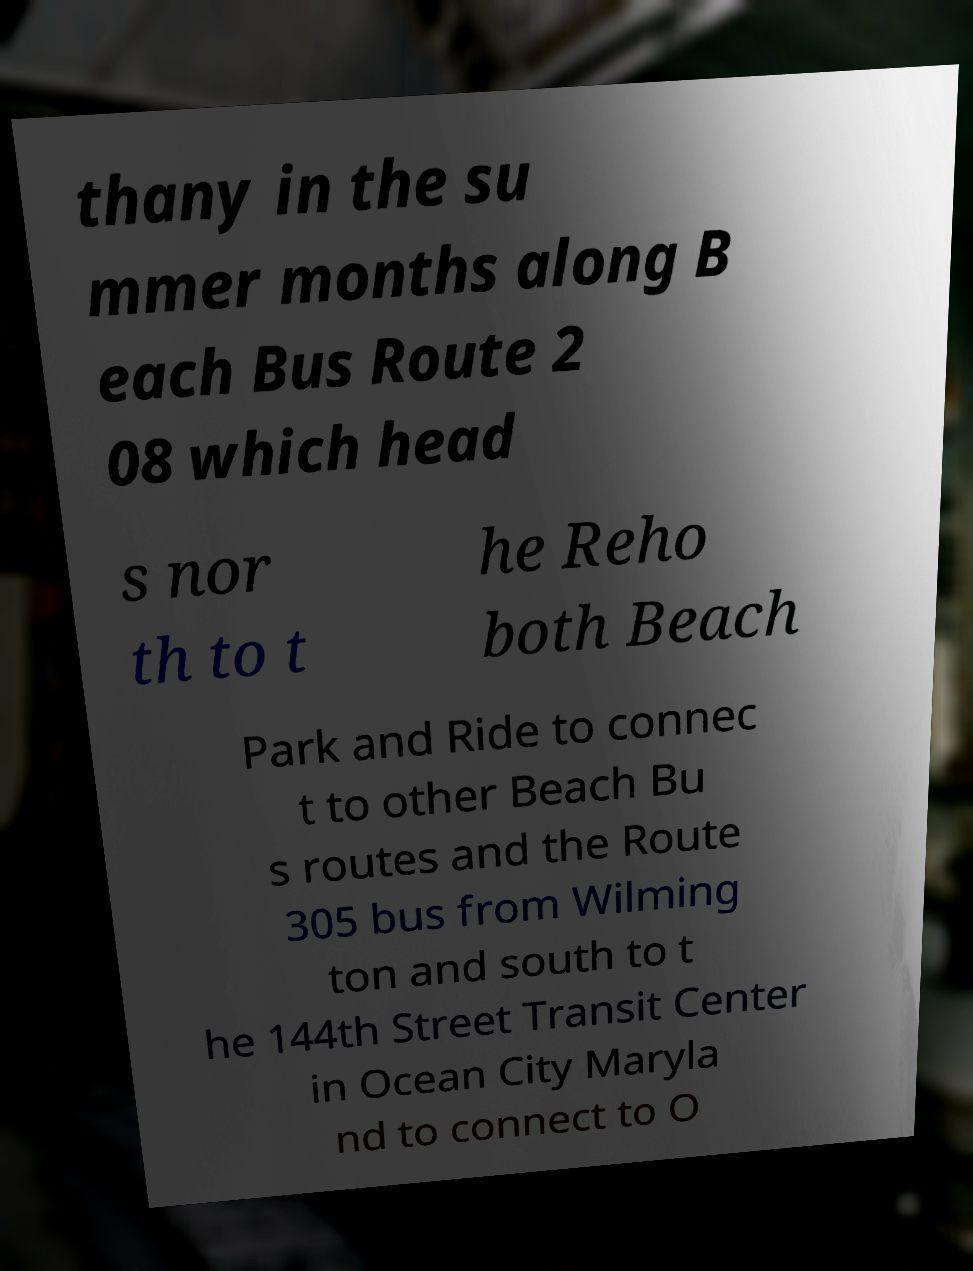There's text embedded in this image that I need extracted. Can you transcribe it verbatim? thany in the su mmer months along B each Bus Route 2 08 which head s nor th to t he Reho both Beach Park and Ride to connec t to other Beach Bu s routes and the Route 305 bus from Wilming ton and south to t he 144th Street Transit Center in Ocean City Maryla nd to connect to O 